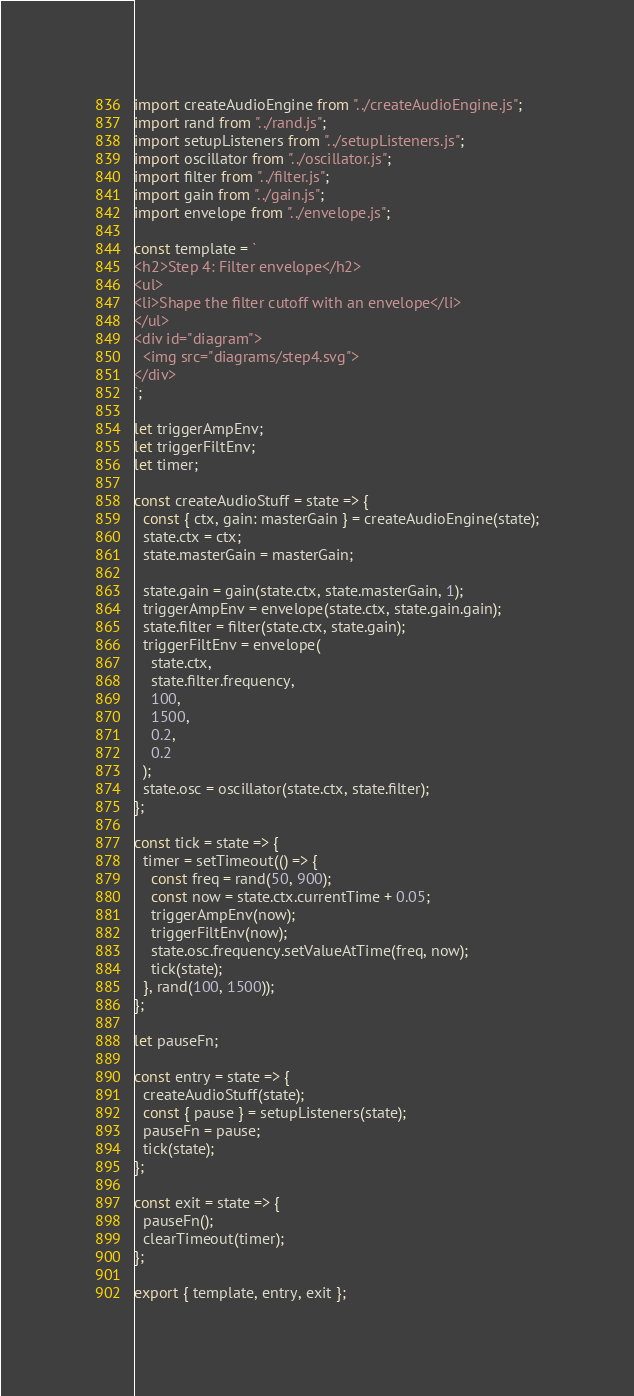<code> <loc_0><loc_0><loc_500><loc_500><_JavaScript_>import createAudioEngine from "../createAudioEngine.js";
import rand from "../rand.js";
import setupListeners from "../setupListeners.js";
import oscillator from "../oscillator.js";
import filter from "../filter.js";
import gain from "../gain.js";
import envelope from "../envelope.js";

const template = `
<h2>Step 4: Filter envelope</h2>
<ul>
<li>Shape the filter cutoff with an envelope</li>
</ul>
<div id="diagram">
  <img src="diagrams/step4.svg">
</div>
`;

let triggerAmpEnv;
let triggerFiltEnv;
let timer;

const createAudioStuff = state => {
  const { ctx, gain: masterGain } = createAudioEngine(state);
  state.ctx = ctx;
  state.masterGain = masterGain;

  state.gain = gain(state.ctx, state.masterGain, 1);
  triggerAmpEnv = envelope(state.ctx, state.gain.gain);
  state.filter = filter(state.ctx, state.gain);
  triggerFiltEnv = envelope(
    state.ctx,
    state.filter.frequency,
    100,
    1500,
    0.2,
    0.2
  );
  state.osc = oscillator(state.ctx, state.filter);
};

const tick = state => {
  timer = setTimeout(() => {
    const freq = rand(50, 900);
    const now = state.ctx.currentTime + 0.05;
    triggerAmpEnv(now);
    triggerFiltEnv(now);
    state.osc.frequency.setValueAtTime(freq, now);
    tick(state);
  }, rand(100, 1500));
};

let pauseFn;

const entry = state => {
  createAudioStuff(state);
  const { pause } = setupListeners(state);
  pauseFn = pause;
  tick(state);
};

const exit = state => {
  pauseFn();
  clearTimeout(timer);
};

export { template, entry, exit };
</code> 